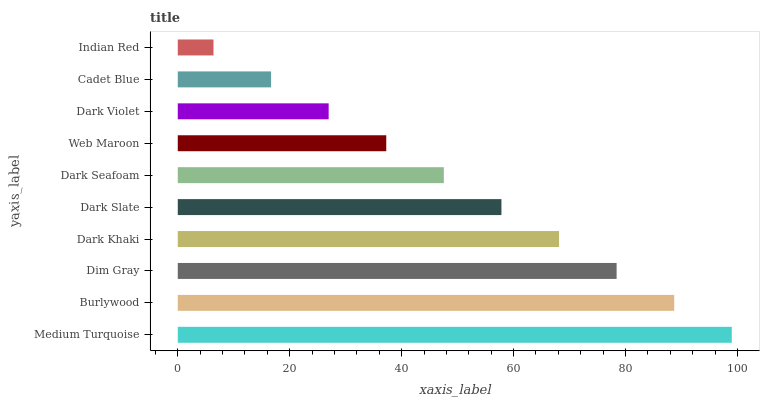Is Indian Red the minimum?
Answer yes or no. Yes. Is Medium Turquoise the maximum?
Answer yes or no. Yes. Is Burlywood the minimum?
Answer yes or no. No. Is Burlywood the maximum?
Answer yes or no. No. Is Medium Turquoise greater than Burlywood?
Answer yes or no. Yes. Is Burlywood less than Medium Turquoise?
Answer yes or no. Yes. Is Burlywood greater than Medium Turquoise?
Answer yes or no. No. Is Medium Turquoise less than Burlywood?
Answer yes or no. No. Is Dark Slate the high median?
Answer yes or no. Yes. Is Dark Seafoam the low median?
Answer yes or no. Yes. Is Web Maroon the high median?
Answer yes or no. No. Is Medium Turquoise the low median?
Answer yes or no. No. 